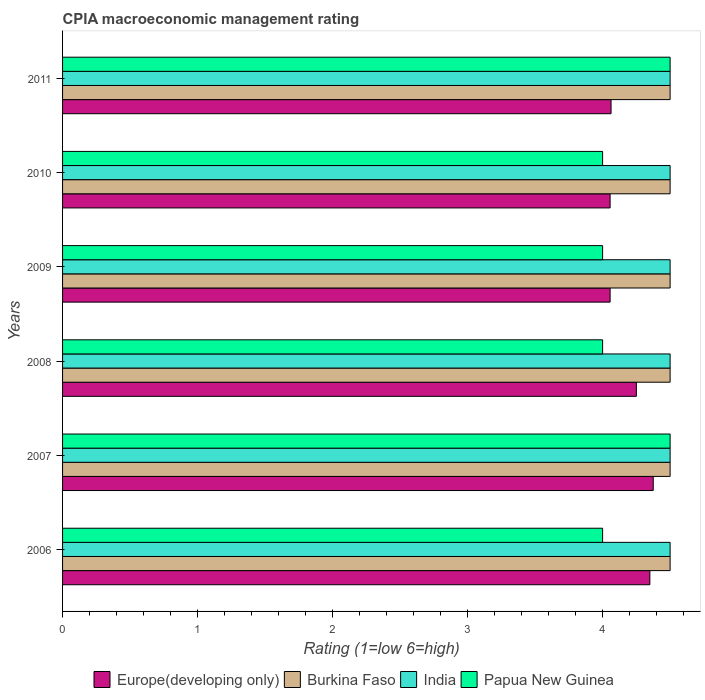What is the label of the 1st group of bars from the top?
Your answer should be compact. 2011. What is the CPIA rating in Europe(developing only) in 2010?
Offer a terse response. 4.06. In which year was the CPIA rating in Papua New Guinea maximum?
Offer a very short reply. 2007. In which year was the CPIA rating in Papua New Guinea minimum?
Offer a very short reply. 2006. What is the total CPIA rating in Papua New Guinea in the graph?
Your answer should be very brief. 25. What is the difference between the CPIA rating in India in 2010 and the CPIA rating in Europe(developing only) in 2011?
Provide a succinct answer. 0.44. What is the average CPIA rating in Papua New Guinea per year?
Offer a terse response. 4.17. In the year 2011, what is the difference between the CPIA rating in Burkina Faso and CPIA rating in Europe(developing only)?
Provide a short and direct response. 0.44. What is the ratio of the CPIA rating in Europe(developing only) in 2006 to that in 2008?
Make the answer very short. 1.02. Is the CPIA rating in India in 2008 less than that in 2010?
Offer a very short reply. No. Is the difference between the CPIA rating in Burkina Faso in 2006 and 2011 greater than the difference between the CPIA rating in Europe(developing only) in 2006 and 2011?
Keep it short and to the point. No. What is the difference between the highest and the second highest CPIA rating in Burkina Faso?
Make the answer very short. 0. What is the difference between the highest and the lowest CPIA rating in Europe(developing only)?
Give a very brief answer. 0.32. Is the sum of the CPIA rating in India in 2010 and 2011 greater than the maximum CPIA rating in Burkina Faso across all years?
Make the answer very short. Yes. What does the 1st bar from the top in 2011 represents?
Provide a succinct answer. Papua New Guinea. What does the 1st bar from the bottom in 2010 represents?
Keep it short and to the point. Europe(developing only). Is it the case that in every year, the sum of the CPIA rating in Burkina Faso and CPIA rating in Europe(developing only) is greater than the CPIA rating in India?
Offer a very short reply. Yes. Are all the bars in the graph horizontal?
Your answer should be very brief. Yes. Does the graph contain any zero values?
Give a very brief answer. No. Does the graph contain grids?
Provide a short and direct response. No. Where does the legend appear in the graph?
Offer a terse response. Bottom center. How are the legend labels stacked?
Offer a very short reply. Horizontal. What is the title of the graph?
Your response must be concise. CPIA macroeconomic management rating. Does "Belize" appear as one of the legend labels in the graph?
Your response must be concise. No. What is the label or title of the Y-axis?
Your answer should be compact. Years. What is the Rating (1=low 6=high) in Europe(developing only) in 2006?
Provide a short and direct response. 4.35. What is the Rating (1=low 6=high) in Burkina Faso in 2006?
Provide a short and direct response. 4.5. What is the Rating (1=low 6=high) of India in 2006?
Give a very brief answer. 4.5. What is the Rating (1=low 6=high) of Papua New Guinea in 2006?
Give a very brief answer. 4. What is the Rating (1=low 6=high) in Europe(developing only) in 2007?
Your answer should be very brief. 4.38. What is the Rating (1=low 6=high) in Burkina Faso in 2007?
Give a very brief answer. 4.5. What is the Rating (1=low 6=high) in India in 2007?
Your answer should be compact. 4.5. What is the Rating (1=low 6=high) of Europe(developing only) in 2008?
Make the answer very short. 4.25. What is the Rating (1=low 6=high) in India in 2008?
Provide a short and direct response. 4.5. What is the Rating (1=low 6=high) in Europe(developing only) in 2009?
Your response must be concise. 4.06. What is the Rating (1=low 6=high) of Burkina Faso in 2009?
Keep it short and to the point. 4.5. What is the Rating (1=low 6=high) in Europe(developing only) in 2010?
Your response must be concise. 4.06. What is the Rating (1=low 6=high) in Burkina Faso in 2010?
Keep it short and to the point. 4.5. What is the Rating (1=low 6=high) of India in 2010?
Your answer should be very brief. 4.5. What is the Rating (1=low 6=high) in Europe(developing only) in 2011?
Make the answer very short. 4.06. What is the Rating (1=low 6=high) of India in 2011?
Your answer should be very brief. 4.5. Across all years, what is the maximum Rating (1=low 6=high) of Europe(developing only)?
Make the answer very short. 4.38. Across all years, what is the maximum Rating (1=low 6=high) in Burkina Faso?
Make the answer very short. 4.5. Across all years, what is the minimum Rating (1=low 6=high) in Europe(developing only)?
Your response must be concise. 4.06. Across all years, what is the minimum Rating (1=low 6=high) in India?
Make the answer very short. 4.5. What is the total Rating (1=low 6=high) in Europe(developing only) in the graph?
Your response must be concise. 25.15. What is the total Rating (1=low 6=high) of Burkina Faso in the graph?
Ensure brevity in your answer.  27. What is the difference between the Rating (1=low 6=high) in Europe(developing only) in 2006 and that in 2007?
Offer a very short reply. -0.03. What is the difference between the Rating (1=low 6=high) of India in 2006 and that in 2007?
Your response must be concise. 0. What is the difference between the Rating (1=low 6=high) in Papua New Guinea in 2006 and that in 2007?
Your answer should be compact. -0.5. What is the difference between the Rating (1=low 6=high) of Europe(developing only) in 2006 and that in 2008?
Your response must be concise. 0.1. What is the difference between the Rating (1=low 6=high) in India in 2006 and that in 2008?
Your response must be concise. 0. What is the difference between the Rating (1=low 6=high) in Papua New Guinea in 2006 and that in 2008?
Provide a short and direct response. 0. What is the difference between the Rating (1=low 6=high) of Europe(developing only) in 2006 and that in 2009?
Provide a succinct answer. 0.29. What is the difference between the Rating (1=low 6=high) in Papua New Guinea in 2006 and that in 2009?
Offer a terse response. 0. What is the difference between the Rating (1=low 6=high) in Europe(developing only) in 2006 and that in 2010?
Provide a short and direct response. 0.29. What is the difference between the Rating (1=low 6=high) of Burkina Faso in 2006 and that in 2010?
Provide a short and direct response. 0. What is the difference between the Rating (1=low 6=high) of Papua New Guinea in 2006 and that in 2010?
Your answer should be very brief. 0. What is the difference between the Rating (1=low 6=high) of Europe(developing only) in 2006 and that in 2011?
Offer a very short reply. 0.29. What is the difference between the Rating (1=low 6=high) of Papua New Guinea in 2006 and that in 2011?
Your answer should be very brief. -0.5. What is the difference between the Rating (1=low 6=high) in Europe(developing only) in 2007 and that in 2008?
Provide a short and direct response. 0.12. What is the difference between the Rating (1=low 6=high) in Papua New Guinea in 2007 and that in 2008?
Make the answer very short. 0.5. What is the difference between the Rating (1=low 6=high) in Europe(developing only) in 2007 and that in 2009?
Keep it short and to the point. 0.32. What is the difference between the Rating (1=low 6=high) in India in 2007 and that in 2009?
Offer a very short reply. 0. What is the difference between the Rating (1=low 6=high) of Papua New Guinea in 2007 and that in 2009?
Make the answer very short. 0.5. What is the difference between the Rating (1=low 6=high) in Europe(developing only) in 2007 and that in 2010?
Ensure brevity in your answer.  0.32. What is the difference between the Rating (1=low 6=high) in Burkina Faso in 2007 and that in 2010?
Provide a short and direct response. 0. What is the difference between the Rating (1=low 6=high) in India in 2007 and that in 2010?
Your answer should be very brief. 0. What is the difference between the Rating (1=low 6=high) of Papua New Guinea in 2007 and that in 2010?
Provide a succinct answer. 0.5. What is the difference between the Rating (1=low 6=high) in Europe(developing only) in 2007 and that in 2011?
Give a very brief answer. 0.31. What is the difference between the Rating (1=low 6=high) in Burkina Faso in 2007 and that in 2011?
Provide a succinct answer. 0. What is the difference between the Rating (1=low 6=high) of India in 2007 and that in 2011?
Ensure brevity in your answer.  0. What is the difference between the Rating (1=low 6=high) of Europe(developing only) in 2008 and that in 2009?
Offer a very short reply. 0.19. What is the difference between the Rating (1=low 6=high) in Burkina Faso in 2008 and that in 2009?
Keep it short and to the point. 0. What is the difference between the Rating (1=low 6=high) of Europe(developing only) in 2008 and that in 2010?
Keep it short and to the point. 0.19. What is the difference between the Rating (1=low 6=high) in Burkina Faso in 2008 and that in 2010?
Provide a succinct answer. 0. What is the difference between the Rating (1=low 6=high) in India in 2008 and that in 2010?
Provide a short and direct response. 0. What is the difference between the Rating (1=low 6=high) of Papua New Guinea in 2008 and that in 2010?
Provide a short and direct response. 0. What is the difference between the Rating (1=low 6=high) of Europe(developing only) in 2008 and that in 2011?
Give a very brief answer. 0.19. What is the difference between the Rating (1=low 6=high) in India in 2008 and that in 2011?
Offer a very short reply. 0. What is the difference between the Rating (1=low 6=high) in Europe(developing only) in 2009 and that in 2010?
Your response must be concise. 0. What is the difference between the Rating (1=low 6=high) in Burkina Faso in 2009 and that in 2010?
Give a very brief answer. 0. What is the difference between the Rating (1=low 6=high) in India in 2009 and that in 2010?
Offer a very short reply. 0. What is the difference between the Rating (1=low 6=high) in Europe(developing only) in 2009 and that in 2011?
Your answer should be compact. -0.01. What is the difference between the Rating (1=low 6=high) in India in 2009 and that in 2011?
Offer a very short reply. 0. What is the difference between the Rating (1=low 6=high) of Papua New Guinea in 2009 and that in 2011?
Provide a succinct answer. -0.5. What is the difference between the Rating (1=low 6=high) of Europe(developing only) in 2010 and that in 2011?
Keep it short and to the point. -0.01. What is the difference between the Rating (1=low 6=high) in Papua New Guinea in 2010 and that in 2011?
Offer a very short reply. -0.5. What is the difference between the Rating (1=low 6=high) in Europe(developing only) in 2006 and the Rating (1=low 6=high) in Burkina Faso in 2007?
Your answer should be very brief. -0.15. What is the difference between the Rating (1=low 6=high) in Europe(developing only) in 2006 and the Rating (1=low 6=high) in India in 2007?
Keep it short and to the point. -0.15. What is the difference between the Rating (1=low 6=high) of Europe(developing only) in 2006 and the Rating (1=low 6=high) of Papua New Guinea in 2007?
Keep it short and to the point. -0.15. What is the difference between the Rating (1=low 6=high) of Burkina Faso in 2006 and the Rating (1=low 6=high) of Papua New Guinea in 2007?
Offer a terse response. 0. What is the difference between the Rating (1=low 6=high) in India in 2006 and the Rating (1=low 6=high) in Papua New Guinea in 2007?
Your response must be concise. 0. What is the difference between the Rating (1=low 6=high) in Europe(developing only) in 2006 and the Rating (1=low 6=high) in India in 2008?
Give a very brief answer. -0.15. What is the difference between the Rating (1=low 6=high) in Europe(developing only) in 2006 and the Rating (1=low 6=high) in Burkina Faso in 2009?
Offer a terse response. -0.15. What is the difference between the Rating (1=low 6=high) of Europe(developing only) in 2006 and the Rating (1=low 6=high) of India in 2009?
Offer a very short reply. -0.15. What is the difference between the Rating (1=low 6=high) of Europe(developing only) in 2006 and the Rating (1=low 6=high) of Papua New Guinea in 2009?
Your response must be concise. 0.35. What is the difference between the Rating (1=low 6=high) in Burkina Faso in 2006 and the Rating (1=low 6=high) in Papua New Guinea in 2009?
Give a very brief answer. 0.5. What is the difference between the Rating (1=low 6=high) in India in 2006 and the Rating (1=low 6=high) in Papua New Guinea in 2009?
Give a very brief answer. 0.5. What is the difference between the Rating (1=low 6=high) of Europe(developing only) in 2006 and the Rating (1=low 6=high) of India in 2010?
Provide a short and direct response. -0.15. What is the difference between the Rating (1=low 6=high) of Burkina Faso in 2006 and the Rating (1=low 6=high) of Papua New Guinea in 2010?
Provide a succinct answer. 0.5. What is the difference between the Rating (1=low 6=high) of India in 2006 and the Rating (1=low 6=high) of Papua New Guinea in 2010?
Your answer should be compact. 0.5. What is the difference between the Rating (1=low 6=high) of Europe(developing only) in 2006 and the Rating (1=low 6=high) of Burkina Faso in 2011?
Your response must be concise. -0.15. What is the difference between the Rating (1=low 6=high) in Europe(developing only) in 2006 and the Rating (1=low 6=high) in India in 2011?
Keep it short and to the point. -0.15. What is the difference between the Rating (1=low 6=high) of Burkina Faso in 2006 and the Rating (1=low 6=high) of Papua New Guinea in 2011?
Your response must be concise. 0. What is the difference between the Rating (1=low 6=high) of India in 2006 and the Rating (1=low 6=high) of Papua New Guinea in 2011?
Your answer should be compact. 0. What is the difference between the Rating (1=low 6=high) in Europe(developing only) in 2007 and the Rating (1=low 6=high) in Burkina Faso in 2008?
Make the answer very short. -0.12. What is the difference between the Rating (1=low 6=high) in Europe(developing only) in 2007 and the Rating (1=low 6=high) in India in 2008?
Give a very brief answer. -0.12. What is the difference between the Rating (1=low 6=high) in Burkina Faso in 2007 and the Rating (1=low 6=high) in India in 2008?
Give a very brief answer. 0. What is the difference between the Rating (1=low 6=high) in Burkina Faso in 2007 and the Rating (1=low 6=high) in Papua New Guinea in 2008?
Give a very brief answer. 0.5. What is the difference between the Rating (1=low 6=high) in India in 2007 and the Rating (1=low 6=high) in Papua New Guinea in 2008?
Your response must be concise. 0.5. What is the difference between the Rating (1=low 6=high) in Europe(developing only) in 2007 and the Rating (1=low 6=high) in Burkina Faso in 2009?
Offer a terse response. -0.12. What is the difference between the Rating (1=low 6=high) in Europe(developing only) in 2007 and the Rating (1=low 6=high) in India in 2009?
Ensure brevity in your answer.  -0.12. What is the difference between the Rating (1=low 6=high) in Europe(developing only) in 2007 and the Rating (1=low 6=high) in Papua New Guinea in 2009?
Provide a succinct answer. 0.38. What is the difference between the Rating (1=low 6=high) of Burkina Faso in 2007 and the Rating (1=low 6=high) of India in 2009?
Give a very brief answer. 0. What is the difference between the Rating (1=low 6=high) of Burkina Faso in 2007 and the Rating (1=low 6=high) of Papua New Guinea in 2009?
Provide a succinct answer. 0.5. What is the difference between the Rating (1=low 6=high) in Europe(developing only) in 2007 and the Rating (1=low 6=high) in Burkina Faso in 2010?
Keep it short and to the point. -0.12. What is the difference between the Rating (1=low 6=high) of Europe(developing only) in 2007 and the Rating (1=low 6=high) of India in 2010?
Offer a very short reply. -0.12. What is the difference between the Rating (1=low 6=high) of Europe(developing only) in 2007 and the Rating (1=low 6=high) of Papua New Guinea in 2010?
Offer a very short reply. 0.38. What is the difference between the Rating (1=low 6=high) in Burkina Faso in 2007 and the Rating (1=low 6=high) in Papua New Guinea in 2010?
Make the answer very short. 0.5. What is the difference between the Rating (1=low 6=high) in Europe(developing only) in 2007 and the Rating (1=low 6=high) in Burkina Faso in 2011?
Keep it short and to the point. -0.12. What is the difference between the Rating (1=low 6=high) of Europe(developing only) in 2007 and the Rating (1=low 6=high) of India in 2011?
Offer a very short reply. -0.12. What is the difference between the Rating (1=low 6=high) in Europe(developing only) in 2007 and the Rating (1=low 6=high) in Papua New Guinea in 2011?
Provide a short and direct response. -0.12. What is the difference between the Rating (1=low 6=high) in Europe(developing only) in 2008 and the Rating (1=low 6=high) in India in 2009?
Provide a succinct answer. -0.25. What is the difference between the Rating (1=low 6=high) of Europe(developing only) in 2008 and the Rating (1=low 6=high) of Papua New Guinea in 2009?
Ensure brevity in your answer.  0.25. What is the difference between the Rating (1=low 6=high) of Burkina Faso in 2008 and the Rating (1=low 6=high) of India in 2009?
Provide a succinct answer. 0. What is the difference between the Rating (1=low 6=high) of Burkina Faso in 2008 and the Rating (1=low 6=high) of Papua New Guinea in 2009?
Your answer should be compact. 0.5. What is the difference between the Rating (1=low 6=high) in India in 2008 and the Rating (1=low 6=high) in Papua New Guinea in 2009?
Keep it short and to the point. 0.5. What is the difference between the Rating (1=low 6=high) of Europe(developing only) in 2008 and the Rating (1=low 6=high) of Burkina Faso in 2010?
Make the answer very short. -0.25. What is the difference between the Rating (1=low 6=high) of Europe(developing only) in 2008 and the Rating (1=low 6=high) of India in 2010?
Your response must be concise. -0.25. What is the difference between the Rating (1=low 6=high) in Europe(developing only) in 2008 and the Rating (1=low 6=high) in Papua New Guinea in 2010?
Your answer should be very brief. 0.25. What is the difference between the Rating (1=low 6=high) of India in 2008 and the Rating (1=low 6=high) of Papua New Guinea in 2010?
Make the answer very short. 0.5. What is the difference between the Rating (1=low 6=high) in Europe(developing only) in 2008 and the Rating (1=low 6=high) in Burkina Faso in 2011?
Give a very brief answer. -0.25. What is the difference between the Rating (1=low 6=high) of Burkina Faso in 2008 and the Rating (1=low 6=high) of India in 2011?
Offer a very short reply. 0. What is the difference between the Rating (1=low 6=high) of Burkina Faso in 2008 and the Rating (1=low 6=high) of Papua New Guinea in 2011?
Keep it short and to the point. 0. What is the difference between the Rating (1=low 6=high) of India in 2008 and the Rating (1=low 6=high) of Papua New Guinea in 2011?
Give a very brief answer. 0. What is the difference between the Rating (1=low 6=high) of Europe(developing only) in 2009 and the Rating (1=low 6=high) of Burkina Faso in 2010?
Offer a very short reply. -0.44. What is the difference between the Rating (1=low 6=high) of Europe(developing only) in 2009 and the Rating (1=low 6=high) of India in 2010?
Your answer should be very brief. -0.44. What is the difference between the Rating (1=low 6=high) in Europe(developing only) in 2009 and the Rating (1=low 6=high) in Papua New Guinea in 2010?
Your answer should be compact. 0.06. What is the difference between the Rating (1=low 6=high) in Burkina Faso in 2009 and the Rating (1=low 6=high) in India in 2010?
Make the answer very short. 0. What is the difference between the Rating (1=low 6=high) of Europe(developing only) in 2009 and the Rating (1=low 6=high) of Burkina Faso in 2011?
Your answer should be compact. -0.44. What is the difference between the Rating (1=low 6=high) in Europe(developing only) in 2009 and the Rating (1=low 6=high) in India in 2011?
Give a very brief answer. -0.44. What is the difference between the Rating (1=low 6=high) in Europe(developing only) in 2009 and the Rating (1=low 6=high) in Papua New Guinea in 2011?
Make the answer very short. -0.44. What is the difference between the Rating (1=low 6=high) of Burkina Faso in 2009 and the Rating (1=low 6=high) of Papua New Guinea in 2011?
Provide a succinct answer. 0. What is the difference between the Rating (1=low 6=high) of India in 2009 and the Rating (1=low 6=high) of Papua New Guinea in 2011?
Offer a very short reply. 0. What is the difference between the Rating (1=low 6=high) of Europe(developing only) in 2010 and the Rating (1=low 6=high) of Burkina Faso in 2011?
Give a very brief answer. -0.44. What is the difference between the Rating (1=low 6=high) in Europe(developing only) in 2010 and the Rating (1=low 6=high) in India in 2011?
Your answer should be compact. -0.44. What is the difference between the Rating (1=low 6=high) in Europe(developing only) in 2010 and the Rating (1=low 6=high) in Papua New Guinea in 2011?
Offer a very short reply. -0.44. What is the difference between the Rating (1=low 6=high) of Burkina Faso in 2010 and the Rating (1=low 6=high) of India in 2011?
Your answer should be very brief. 0. What is the difference between the Rating (1=low 6=high) of India in 2010 and the Rating (1=low 6=high) of Papua New Guinea in 2011?
Provide a short and direct response. 0. What is the average Rating (1=low 6=high) of Europe(developing only) per year?
Offer a very short reply. 4.19. What is the average Rating (1=low 6=high) of Burkina Faso per year?
Your response must be concise. 4.5. What is the average Rating (1=low 6=high) in Papua New Guinea per year?
Your answer should be very brief. 4.17. In the year 2006, what is the difference between the Rating (1=low 6=high) in Europe(developing only) and Rating (1=low 6=high) in Burkina Faso?
Your answer should be very brief. -0.15. In the year 2006, what is the difference between the Rating (1=low 6=high) in Europe(developing only) and Rating (1=low 6=high) in India?
Give a very brief answer. -0.15. In the year 2006, what is the difference between the Rating (1=low 6=high) of Europe(developing only) and Rating (1=low 6=high) of Papua New Guinea?
Offer a very short reply. 0.35. In the year 2006, what is the difference between the Rating (1=low 6=high) in Burkina Faso and Rating (1=low 6=high) in India?
Offer a very short reply. 0. In the year 2006, what is the difference between the Rating (1=low 6=high) in India and Rating (1=low 6=high) in Papua New Guinea?
Your response must be concise. 0.5. In the year 2007, what is the difference between the Rating (1=low 6=high) in Europe(developing only) and Rating (1=low 6=high) in Burkina Faso?
Ensure brevity in your answer.  -0.12. In the year 2007, what is the difference between the Rating (1=low 6=high) in Europe(developing only) and Rating (1=low 6=high) in India?
Provide a succinct answer. -0.12. In the year 2007, what is the difference between the Rating (1=low 6=high) of Europe(developing only) and Rating (1=low 6=high) of Papua New Guinea?
Your response must be concise. -0.12. In the year 2007, what is the difference between the Rating (1=low 6=high) in Burkina Faso and Rating (1=low 6=high) in India?
Offer a very short reply. 0. In the year 2007, what is the difference between the Rating (1=low 6=high) in India and Rating (1=low 6=high) in Papua New Guinea?
Provide a succinct answer. 0. In the year 2008, what is the difference between the Rating (1=low 6=high) in Europe(developing only) and Rating (1=low 6=high) in Burkina Faso?
Your answer should be compact. -0.25. In the year 2008, what is the difference between the Rating (1=low 6=high) in Europe(developing only) and Rating (1=low 6=high) in India?
Make the answer very short. -0.25. In the year 2008, what is the difference between the Rating (1=low 6=high) in India and Rating (1=low 6=high) in Papua New Guinea?
Your answer should be compact. 0.5. In the year 2009, what is the difference between the Rating (1=low 6=high) in Europe(developing only) and Rating (1=low 6=high) in Burkina Faso?
Offer a very short reply. -0.44. In the year 2009, what is the difference between the Rating (1=low 6=high) of Europe(developing only) and Rating (1=low 6=high) of India?
Your answer should be compact. -0.44. In the year 2009, what is the difference between the Rating (1=low 6=high) in Europe(developing only) and Rating (1=low 6=high) in Papua New Guinea?
Keep it short and to the point. 0.06. In the year 2009, what is the difference between the Rating (1=low 6=high) in Burkina Faso and Rating (1=low 6=high) in India?
Your answer should be compact. 0. In the year 2010, what is the difference between the Rating (1=low 6=high) of Europe(developing only) and Rating (1=low 6=high) of Burkina Faso?
Your response must be concise. -0.44. In the year 2010, what is the difference between the Rating (1=low 6=high) of Europe(developing only) and Rating (1=low 6=high) of India?
Offer a very short reply. -0.44. In the year 2010, what is the difference between the Rating (1=low 6=high) in Europe(developing only) and Rating (1=low 6=high) in Papua New Guinea?
Give a very brief answer. 0.06. In the year 2010, what is the difference between the Rating (1=low 6=high) of Burkina Faso and Rating (1=low 6=high) of Papua New Guinea?
Give a very brief answer. 0.5. In the year 2010, what is the difference between the Rating (1=low 6=high) in India and Rating (1=low 6=high) in Papua New Guinea?
Your answer should be compact. 0.5. In the year 2011, what is the difference between the Rating (1=low 6=high) of Europe(developing only) and Rating (1=low 6=high) of Burkina Faso?
Your response must be concise. -0.44. In the year 2011, what is the difference between the Rating (1=low 6=high) in Europe(developing only) and Rating (1=low 6=high) in India?
Provide a short and direct response. -0.44. In the year 2011, what is the difference between the Rating (1=low 6=high) of Europe(developing only) and Rating (1=low 6=high) of Papua New Guinea?
Make the answer very short. -0.44. In the year 2011, what is the difference between the Rating (1=low 6=high) in Burkina Faso and Rating (1=low 6=high) in Papua New Guinea?
Your response must be concise. 0. In the year 2011, what is the difference between the Rating (1=low 6=high) of India and Rating (1=low 6=high) of Papua New Guinea?
Provide a short and direct response. 0. What is the ratio of the Rating (1=low 6=high) in Europe(developing only) in 2006 to that in 2007?
Make the answer very short. 0.99. What is the ratio of the Rating (1=low 6=high) in Papua New Guinea in 2006 to that in 2007?
Offer a terse response. 0.89. What is the ratio of the Rating (1=low 6=high) of Europe(developing only) in 2006 to that in 2008?
Provide a succinct answer. 1.02. What is the ratio of the Rating (1=low 6=high) of Europe(developing only) in 2006 to that in 2009?
Provide a short and direct response. 1.07. What is the ratio of the Rating (1=low 6=high) of India in 2006 to that in 2009?
Keep it short and to the point. 1. What is the ratio of the Rating (1=low 6=high) in Europe(developing only) in 2006 to that in 2010?
Make the answer very short. 1.07. What is the ratio of the Rating (1=low 6=high) of Burkina Faso in 2006 to that in 2010?
Provide a succinct answer. 1. What is the ratio of the Rating (1=low 6=high) in Papua New Guinea in 2006 to that in 2010?
Make the answer very short. 1. What is the ratio of the Rating (1=low 6=high) of Europe(developing only) in 2006 to that in 2011?
Ensure brevity in your answer.  1.07. What is the ratio of the Rating (1=low 6=high) of Burkina Faso in 2006 to that in 2011?
Provide a succinct answer. 1. What is the ratio of the Rating (1=low 6=high) in Papua New Guinea in 2006 to that in 2011?
Give a very brief answer. 0.89. What is the ratio of the Rating (1=low 6=high) in Europe(developing only) in 2007 to that in 2008?
Your response must be concise. 1.03. What is the ratio of the Rating (1=low 6=high) of Burkina Faso in 2007 to that in 2008?
Provide a succinct answer. 1. What is the ratio of the Rating (1=low 6=high) of Papua New Guinea in 2007 to that in 2008?
Give a very brief answer. 1.12. What is the ratio of the Rating (1=low 6=high) in Europe(developing only) in 2007 to that in 2009?
Offer a terse response. 1.08. What is the ratio of the Rating (1=low 6=high) in Burkina Faso in 2007 to that in 2009?
Offer a terse response. 1. What is the ratio of the Rating (1=low 6=high) in India in 2007 to that in 2009?
Give a very brief answer. 1. What is the ratio of the Rating (1=low 6=high) in Papua New Guinea in 2007 to that in 2009?
Ensure brevity in your answer.  1.12. What is the ratio of the Rating (1=low 6=high) in Europe(developing only) in 2007 to that in 2010?
Provide a short and direct response. 1.08. What is the ratio of the Rating (1=low 6=high) of Burkina Faso in 2007 to that in 2010?
Offer a very short reply. 1. What is the ratio of the Rating (1=low 6=high) of Europe(developing only) in 2008 to that in 2009?
Your answer should be compact. 1.05. What is the ratio of the Rating (1=low 6=high) of Burkina Faso in 2008 to that in 2009?
Provide a succinct answer. 1. What is the ratio of the Rating (1=low 6=high) of India in 2008 to that in 2009?
Your response must be concise. 1. What is the ratio of the Rating (1=low 6=high) in Papua New Guinea in 2008 to that in 2009?
Your response must be concise. 1. What is the ratio of the Rating (1=low 6=high) of Europe(developing only) in 2008 to that in 2010?
Give a very brief answer. 1.05. What is the ratio of the Rating (1=low 6=high) in Burkina Faso in 2008 to that in 2010?
Provide a succinct answer. 1. What is the ratio of the Rating (1=low 6=high) in Europe(developing only) in 2008 to that in 2011?
Your response must be concise. 1.05. What is the ratio of the Rating (1=low 6=high) of Burkina Faso in 2009 to that in 2010?
Your answer should be very brief. 1. What is the ratio of the Rating (1=low 6=high) in Papua New Guinea in 2009 to that in 2010?
Give a very brief answer. 1. What is the ratio of the Rating (1=low 6=high) in Papua New Guinea in 2009 to that in 2011?
Keep it short and to the point. 0.89. What is the ratio of the Rating (1=low 6=high) of India in 2010 to that in 2011?
Keep it short and to the point. 1. What is the difference between the highest and the second highest Rating (1=low 6=high) in Europe(developing only)?
Provide a succinct answer. 0.03. What is the difference between the highest and the second highest Rating (1=low 6=high) in India?
Your response must be concise. 0. What is the difference between the highest and the second highest Rating (1=low 6=high) in Papua New Guinea?
Make the answer very short. 0. What is the difference between the highest and the lowest Rating (1=low 6=high) of Europe(developing only)?
Offer a terse response. 0.32. 